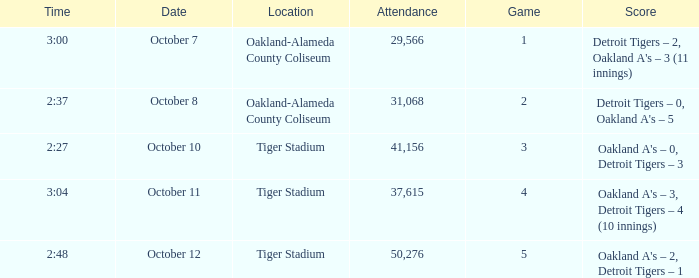What is the number of people in attendance when the time is 3:00? 29566.0. 